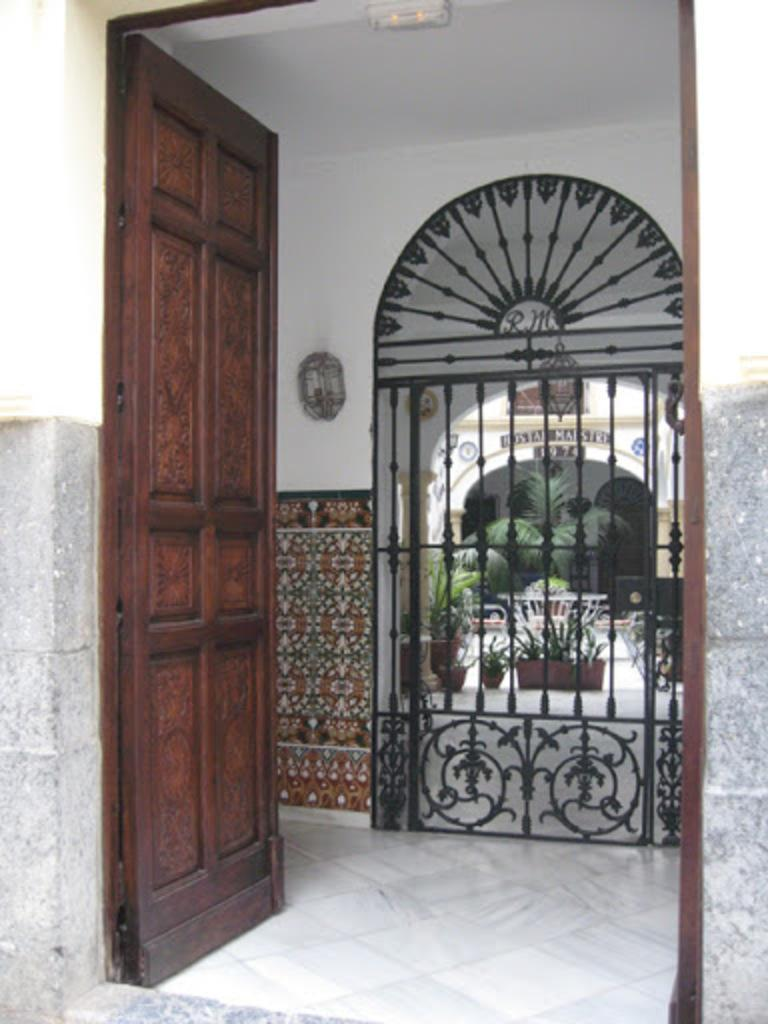What type of structure can be seen in the image? There is a door in the image. What is located near the door? There is a fence in the image. What type of flooring is visible in the image? There is a white marble floor in the image. What type of vegetation is present in the image? There are plants in the image. What type of sheet is draped over the bed in the image? There is no bed or sheet present in the image. 